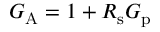Convert formula to latex. <formula><loc_0><loc_0><loc_500><loc_500>G _ { A } = 1 + R _ { s } G _ { p }</formula> 